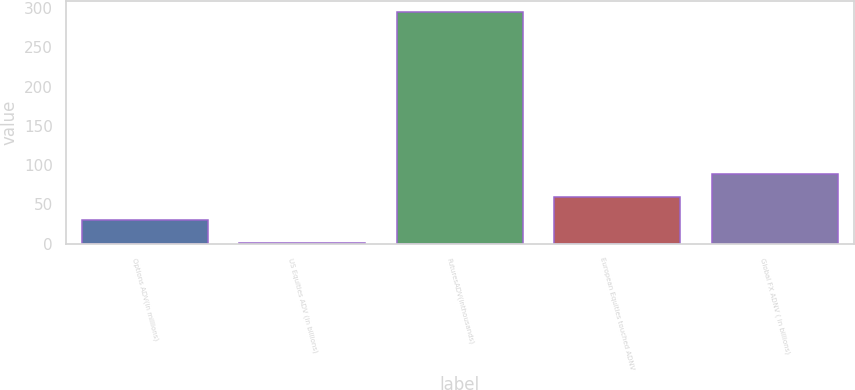<chart> <loc_0><loc_0><loc_500><loc_500><bar_chart><fcel>Options ADV(in millions)<fcel>US Equities ADV (in billions)<fcel>FuturesADV(inthousands)<fcel>European Equities touched ADNV<fcel>Global FX ADNV ( in billions)<nl><fcel>30.65<fcel>1.3<fcel>294.8<fcel>60<fcel>89.35<nl></chart> 